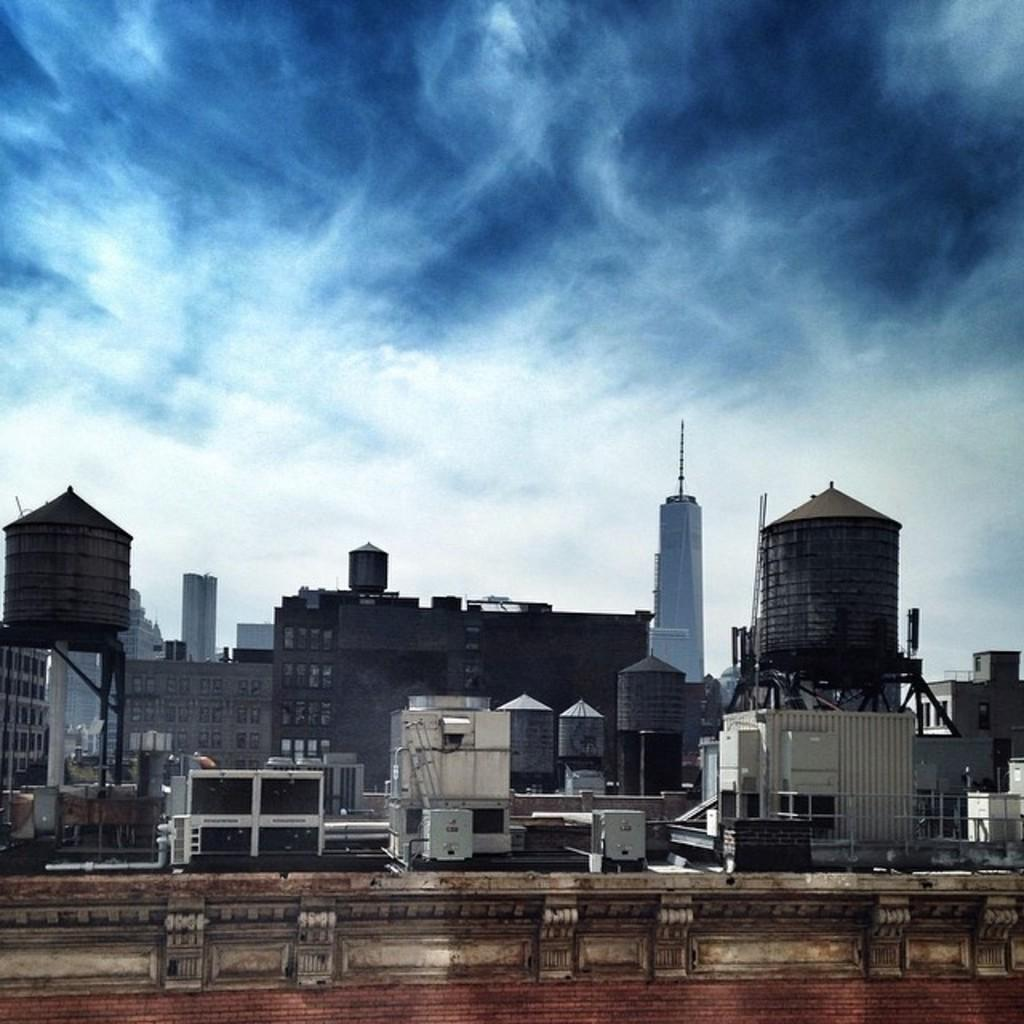What type of structures can be seen in the image? There are buildings in the image. What military vehicles are present in the image? There are tanks in the image. What is visible at the top of the image? The sky is visible at the top of the image. What is the income of the person who owns the tanks in the image? There is no information about the income of the person who owns the tanks in the image. What type of voyage are the tanks embarking on in the image? There is no indication of a voyage in the image; the tanks are stationary. 